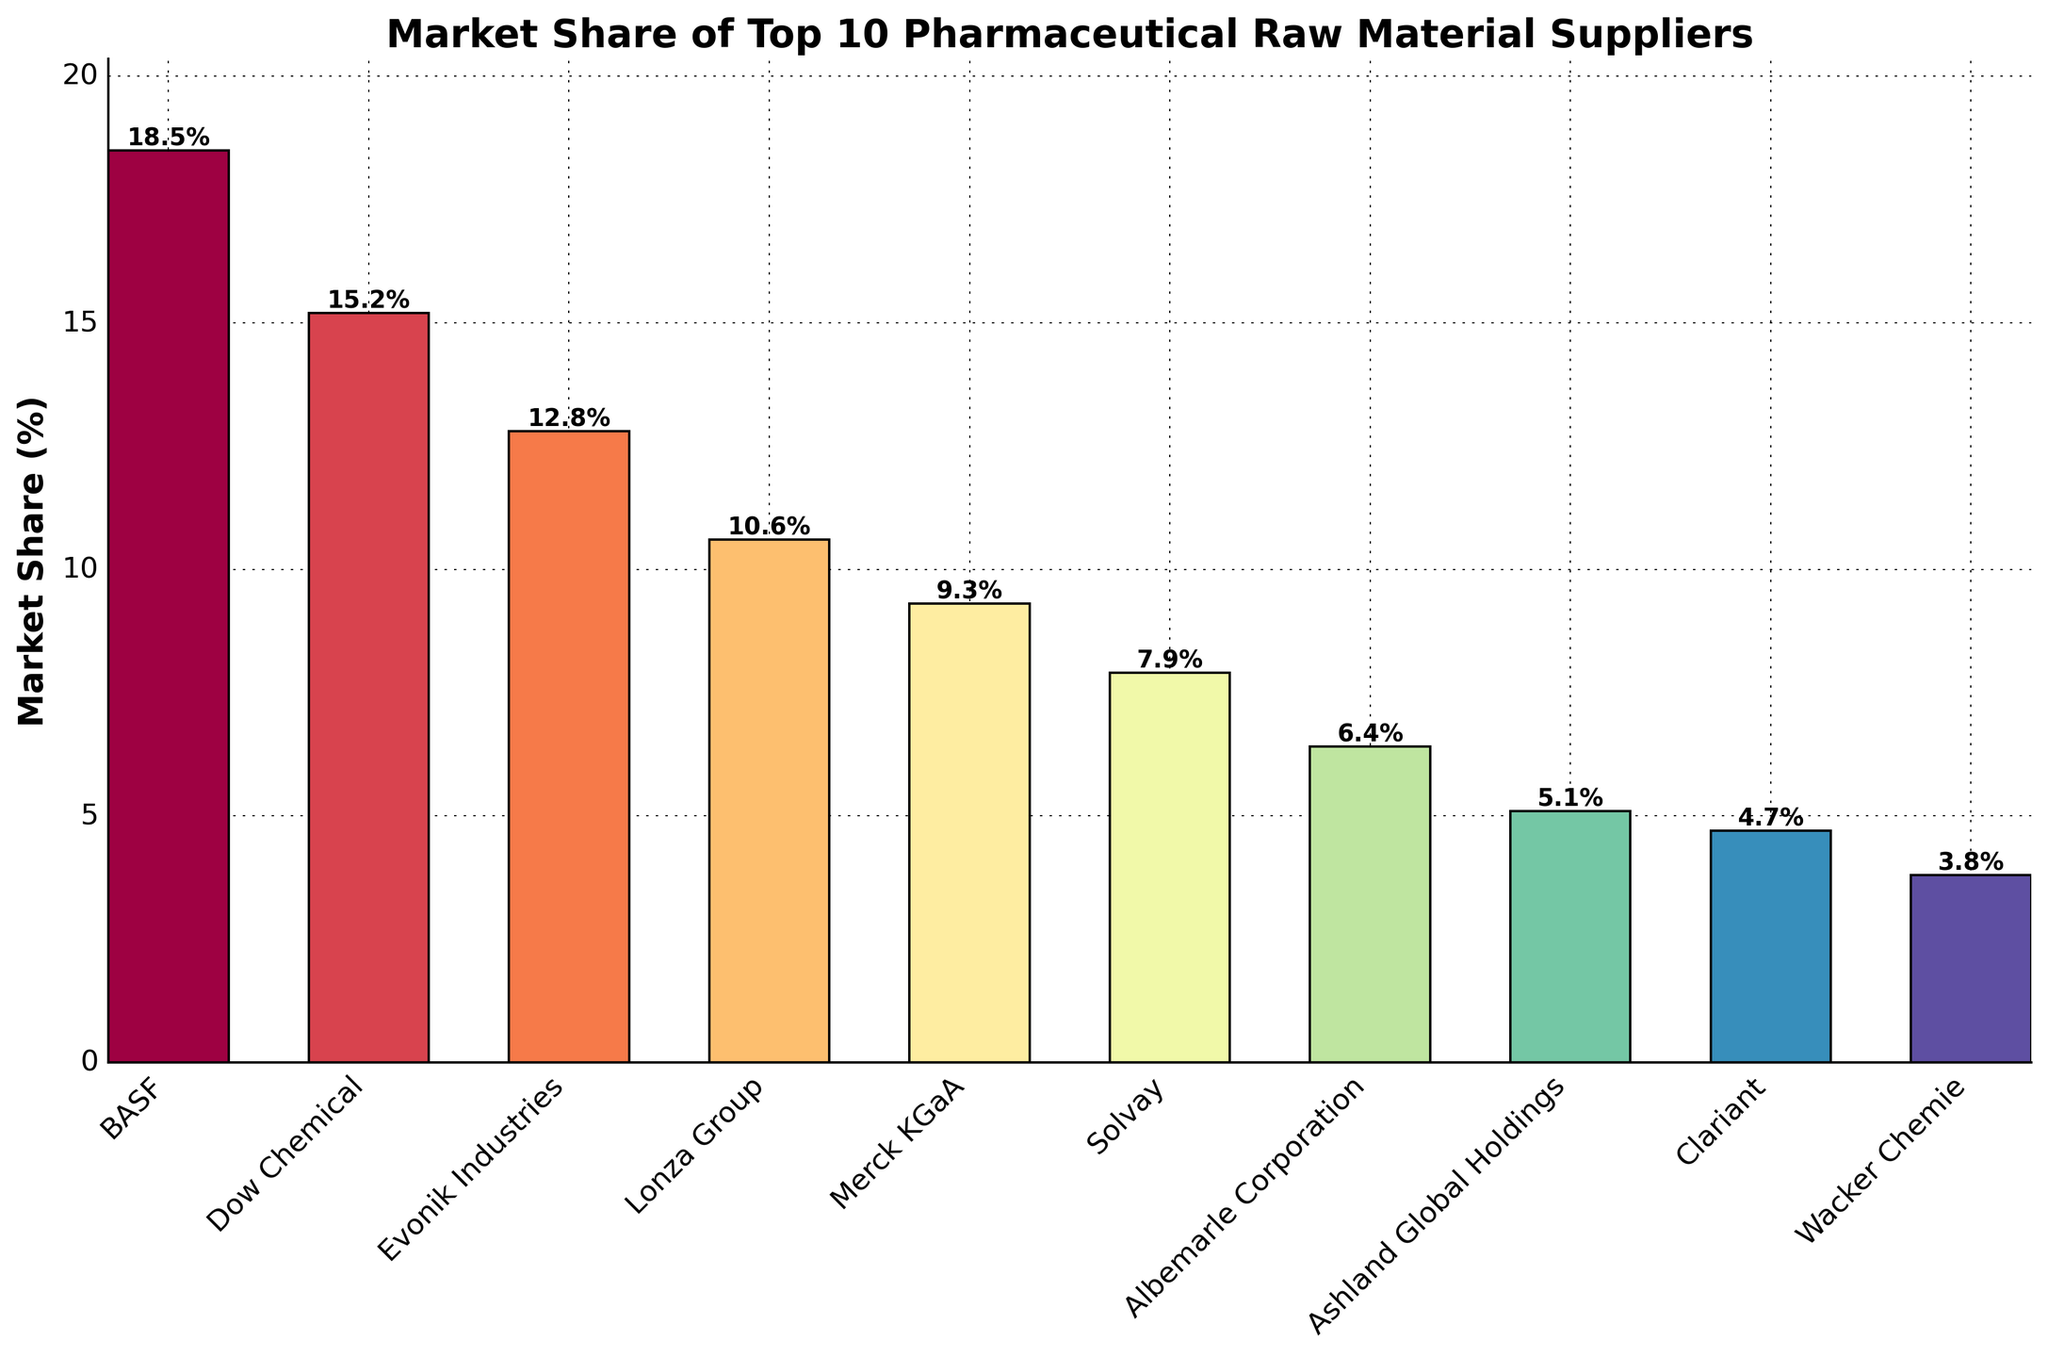Which company has the highest market share? By observing the bar chart, the tallest bar represents the company with the highest market share, which is BASF with 18.5%.
Answer: BASF Which company has the lowest market share? The shortest bar on the chart represents the company with the lowest market share, which is Wacker Chemie with 3.8%.
Answer: Wacker Chemie What is the difference in market share between BASF and Dow Chemical? BASF has a market share of 18.5%, while Dow Chemical has 15.2%. The difference is 18.5% - 15.2% = 3.3%.
Answer: 3.3% Which companies have a market share greater than 10%? Companies with bars taller than the 10% mark are BASF, Dow Chemical, Evonik Industries, and Lonza Group.
Answer: BASF, Dow Chemical, Evonik Industries, Lonza Group What is the combined market share of the top three companies? The top three companies by market share are BASF (18.5%), Dow Chemical (15.2%), and Evonik Industries (12.8%). The combined market share is 18.5% + 15.2% + 12.8% = 46.5%.
Answer: 46.5% What is the average market share of all listed companies? Sum all market shares: 18.5 + 15.2 + 12.8 + 10.6 + 9.3 + 7.9 + 6.4 + 5.1 + 4.7 + 3.8 = 94.3. The average is 94.3 / 10 = 9.43%.
Answer: 9.43% How much higher is BASF’s market share compared to the average market share? The average market share is 9.43%. BASF’s market share is 18.5%. The difference is 18.5% - 9.43% = 9.07%.
Answer: 9.07% Which company has a market share closest to the median of the dataset? First, sort the market shares: 3.8, 4.7, 5.1, 6.4, 7.9, 9.3, 10.6, 12.8, 15.2, 18.5. The median is the middle value, or average of the two middle values, 7.9% and 9.3%. Therefore, the median is (7.9 + 9.3)/2 = 8.6%. Merck KGaA with 9.3% is closest to 8.6%.
Answer: Merck KGaA What is the total market share of companies with less than 5% market share? Companies with less than 5% market share are Clariant (4.7%) and Wacker Chemie (3.8%). The combined market share is 4.7% + 3.8% = 8.5%.
Answer: 8.5% Which company lies exactly in the middle of the market share ranking? In a sorted list of companies by market share, the 5th and 6th ranked companies will lie in the middle (since there are 10 companies). These companies are Merck KGaA (9.3%) and Solvay (7.9%).
Answer: Merck KGaA, Solvay 